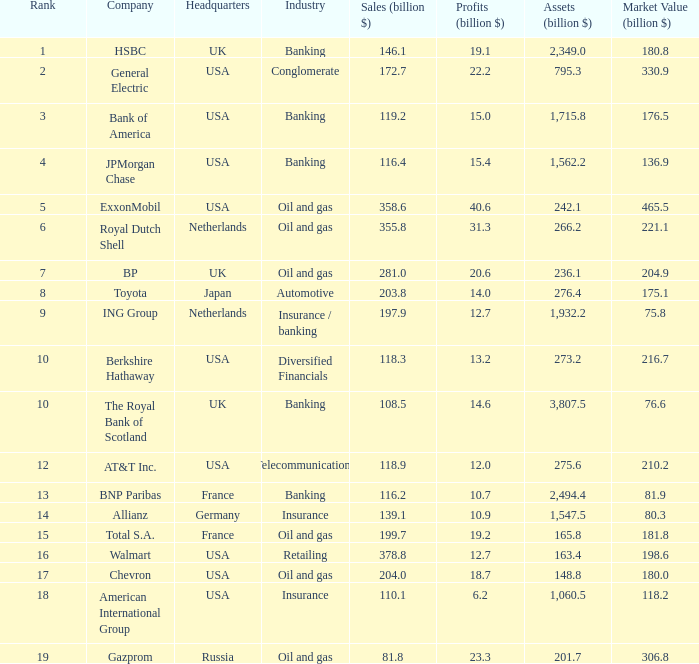In which industry does a business with a market valuation of 8 Insurance. 